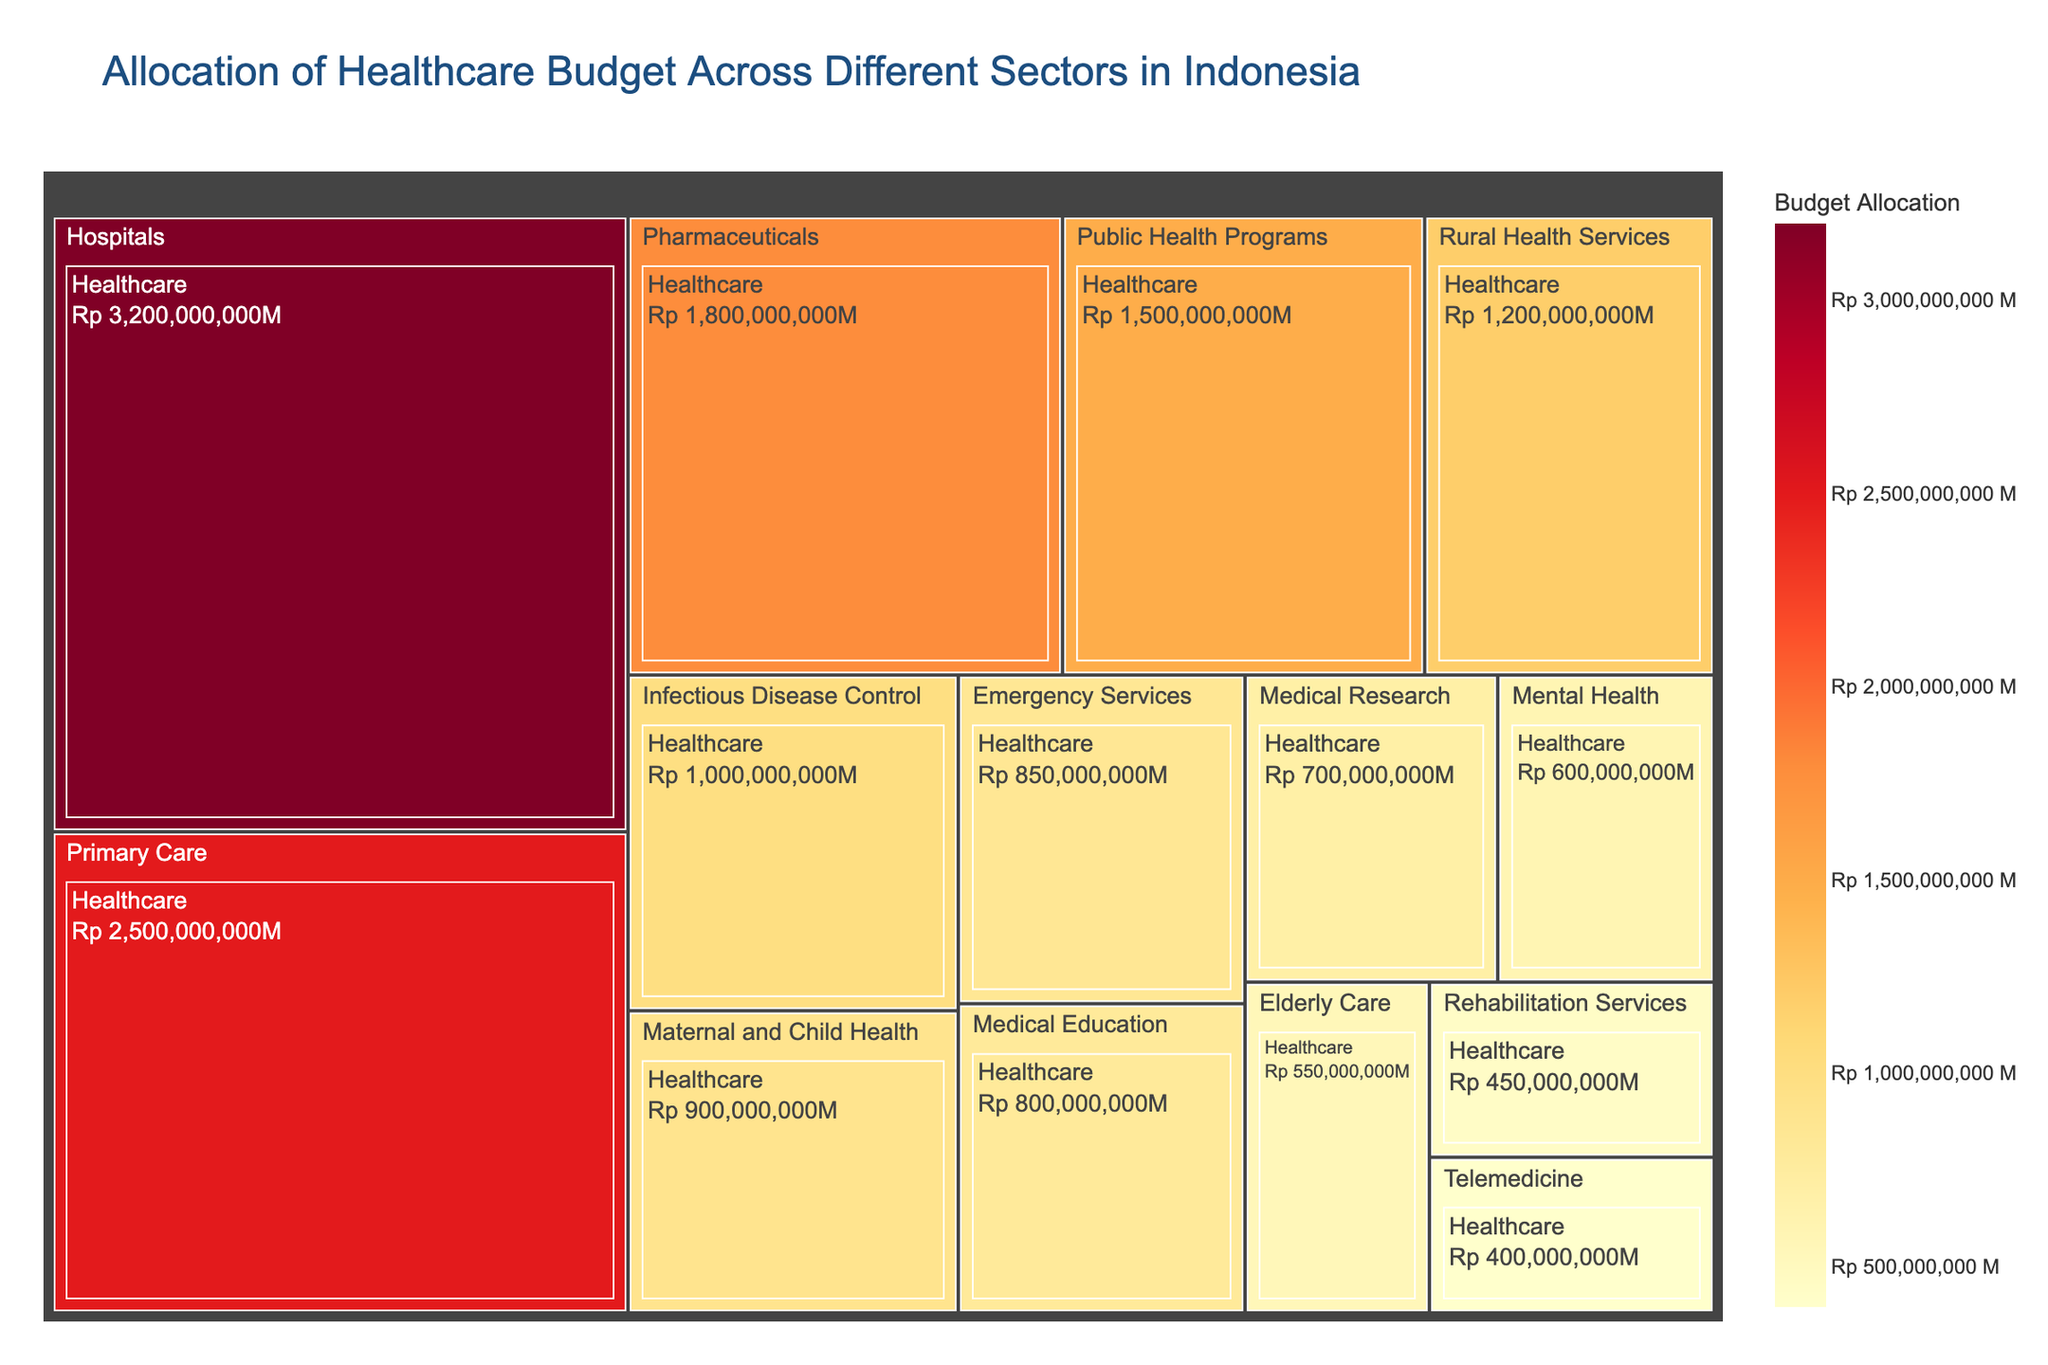What is the title of the treemap? The title of the treemap can be found at the top of the figure.
Answer: Allocation of Healthcare Budget Across Different Sectors in Indonesia Which healthcare category has the highest budget allocation? You can determine which category has the highest budget allocation by looking at the largest rectangle in the treemap and its value.
Answer: Hospitals What is the budget allocation for Rural Health Services? Find the rectangle labeled "Rural Health Services" and check the budget allocation value displayed on it.
Answer: Rp 1,200,000,000 How much more budget is allocated to Hospitals compared to Telemedicine? Find the budget allocation for both Hospitals and Telemedicine, subtract the allocation for Telemedicine from that of Hospitals. Hospitals: Rp 3,200,000,000, Telemedicine: Rp 400,000,000. Difference: Rp 3,200,000,000 - Rp 400,000,000 = Rp 2,800,000,000
Answer: Rp 2,800,000,000 Which healthcare categories have a budget of less than Rp 1,000,000,000? Identify all rectangles with budget allocations less than Rp 1,000,000,000. These are the categories with values below this threshold.
Answer: Medical Education, Mental Health, Elderly Care, Rehabilitation Services, Telemedicine What is the combined budget allocation for Public Health Programs and Primary Care? Find the budget allocations for both categories and sum them. Public Health Programs: Rp 1,500,000,000, Primary Care: Rp 2,500,000,000. Combined: Rp 1,500,000,000 + Rp 2,500,000,000 = Rp 4,000,000,000
Answer: Rp 4,000,000,000 Is the budget for Emergency Services higher than that for Infectious Disease Control? Compare the budget allocations for both categories. Emergency Services: Rp 850,000,000, Infectious Disease Control: Rp 1,000,000,000.
Answer: No What fraction of the total healthcare budget is allocated to Pharmaceuticals? Calculate the total healthcare budget by summing all the allocations, then find the fraction allocated to Pharmaceuticals. Total budget is Rp 16,800,000,000. Pharmaceuticals: Rp 1,800,000,000. Fraction: Rp 1,800,000,000 / Rp 16,800,000,000 = 0.107
Answer: 0.107 How does the budget allocation for Elderly Care compare to that for Mental Health? Check the budget allocations for both categories and compare them. Elderly Care: Rp 550,000,000, Mental Health: Rp 600,000,000. Elderly Care is less than Mental Health.
Answer: Less What is the average budget allocation for all healthcare categories? Sum the budget allocations for all categories and divide by the number of categories. Total budget: Rp 16,800,000,000. Number of categories: 14. Average budget: Rp 16,800,000,000 / 14 = Rp 1,200,000,000
Answer: Rp 1,200,000,000 